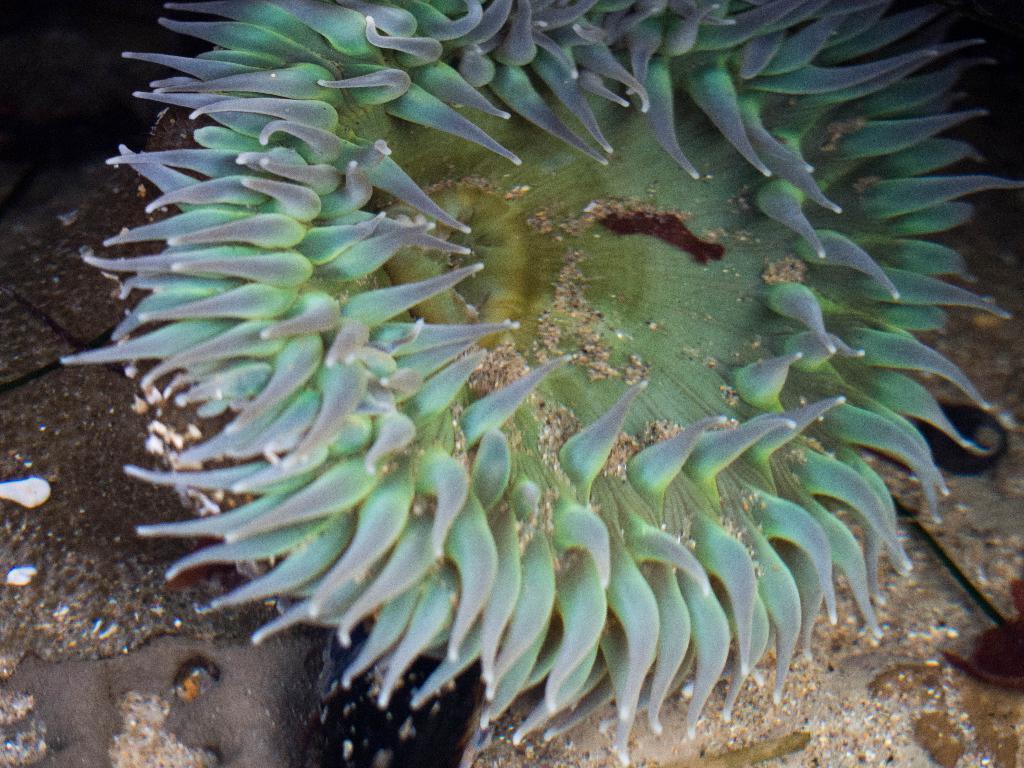Can you describe this image briefly? In this image, we can see an underwater marine object. 